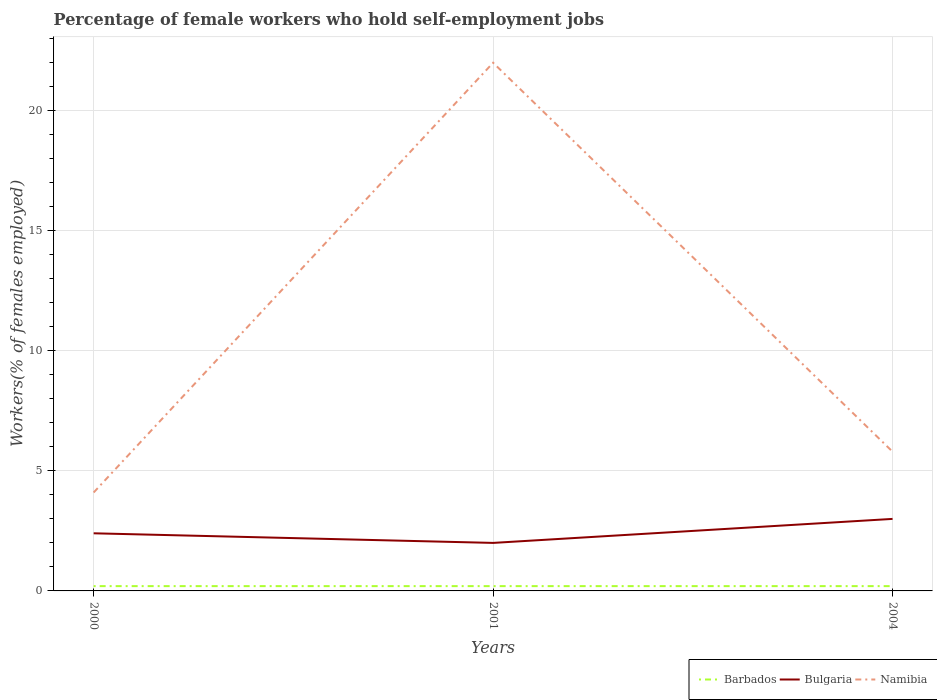How many different coloured lines are there?
Your answer should be very brief. 3. Does the line corresponding to Barbados intersect with the line corresponding to Namibia?
Keep it short and to the point. No. Across all years, what is the maximum percentage of self-employed female workers in Bulgaria?
Your answer should be compact. 2. What is the total percentage of self-employed female workers in Namibia in the graph?
Your answer should be very brief. -17.9. What is the difference between the highest and the lowest percentage of self-employed female workers in Bulgaria?
Offer a very short reply. 1. Is the percentage of self-employed female workers in Barbados strictly greater than the percentage of self-employed female workers in Bulgaria over the years?
Your response must be concise. Yes. How many lines are there?
Provide a short and direct response. 3. Does the graph contain grids?
Keep it short and to the point. Yes. Where does the legend appear in the graph?
Give a very brief answer. Bottom right. How many legend labels are there?
Offer a terse response. 3. What is the title of the graph?
Give a very brief answer. Percentage of female workers who hold self-employment jobs. What is the label or title of the X-axis?
Keep it short and to the point. Years. What is the label or title of the Y-axis?
Keep it short and to the point. Workers(% of females employed). What is the Workers(% of females employed) of Barbados in 2000?
Your response must be concise. 0.2. What is the Workers(% of females employed) of Bulgaria in 2000?
Ensure brevity in your answer.  2.4. What is the Workers(% of females employed) in Namibia in 2000?
Your response must be concise. 4.1. What is the Workers(% of females employed) in Barbados in 2001?
Give a very brief answer. 0.2. What is the Workers(% of females employed) in Bulgaria in 2001?
Your answer should be compact. 2. What is the Workers(% of females employed) in Barbados in 2004?
Your answer should be compact. 0.2. What is the Workers(% of females employed) in Bulgaria in 2004?
Ensure brevity in your answer.  3. What is the Workers(% of females employed) of Namibia in 2004?
Provide a succinct answer. 5.8. Across all years, what is the maximum Workers(% of females employed) in Barbados?
Ensure brevity in your answer.  0.2. Across all years, what is the maximum Workers(% of females employed) in Bulgaria?
Your answer should be compact. 3. Across all years, what is the maximum Workers(% of females employed) of Namibia?
Provide a succinct answer. 22. Across all years, what is the minimum Workers(% of females employed) in Barbados?
Provide a short and direct response. 0.2. Across all years, what is the minimum Workers(% of females employed) in Bulgaria?
Make the answer very short. 2. Across all years, what is the minimum Workers(% of females employed) in Namibia?
Give a very brief answer. 4.1. What is the total Workers(% of females employed) of Namibia in the graph?
Give a very brief answer. 31.9. What is the difference between the Workers(% of females employed) in Namibia in 2000 and that in 2001?
Offer a terse response. -17.9. What is the difference between the Workers(% of females employed) in Barbados in 2000 and that in 2004?
Ensure brevity in your answer.  0. What is the difference between the Workers(% of females employed) in Bulgaria in 2000 and that in 2004?
Provide a short and direct response. -0.6. What is the difference between the Workers(% of females employed) in Barbados in 2000 and the Workers(% of females employed) in Bulgaria in 2001?
Give a very brief answer. -1.8. What is the difference between the Workers(% of females employed) of Barbados in 2000 and the Workers(% of females employed) of Namibia in 2001?
Provide a succinct answer. -21.8. What is the difference between the Workers(% of females employed) in Bulgaria in 2000 and the Workers(% of females employed) in Namibia in 2001?
Provide a short and direct response. -19.6. What is the difference between the Workers(% of females employed) in Bulgaria in 2000 and the Workers(% of females employed) in Namibia in 2004?
Offer a very short reply. -3.4. What is the difference between the Workers(% of females employed) of Bulgaria in 2001 and the Workers(% of females employed) of Namibia in 2004?
Keep it short and to the point. -3.8. What is the average Workers(% of females employed) in Barbados per year?
Your answer should be compact. 0.2. What is the average Workers(% of females employed) in Bulgaria per year?
Provide a succinct answer. 2.47. What is the average Workers(% of females employed) of Namibia per year?
Keep it short and to the point. 10.63. In the year 2001, what is the difference between the Workers(% of females employed) in Barbados and Workers(% of females employed) in Bulgaria?
Your response must be concise. -1.8. In the year 2001, what is the difference between the Workers(% of females employed) of Barbados and Workers(% of females employed) of Namibia?
Make the answer very short. -21.8. In the year 2001, what is the difference between the Workers(% of females employed) of Bulgaria and Workers(% of females employed) of Namibia?
Your answer should be compact. -20. In the year 2004, what is the difference between the Workers(% of females employed) in Barbados and Workers(% of females employed) in Namibia?
Make the answer very short. -5.6. In the year 2004, what is the difference between the Workers(% of females employed) in Bulgaria and Workers(% of females employed) in Namibia?
Provide a short and direct response. -2.8. What is the ratio of the Workers(% of females employed) of Barbados in 2000 to that in 2001?
Ensure brevity in your answer.  1. What is the ratio of the Workers(% of females employed) of Namibia in 2000 to that in 2001?
Offer a terse response. 0.19. What is the ratio of the Workers(% of females employed) in Bulgaria in 2000 to that in 2004?
Offer a terse response. 0.8. What is the ratio of the Workers(% of females employed) of Namibia in 2000 to that in 2004?
Keep it short and to the point. 0.71. What is the ratio of the Workers(% of females employed) in Namibia in 2001 to that in 2004?
Ensure brevity in your answer.  3.79. What is the difference between the highest and the second highest Workers(% of females employed) in Bulgaria?
Make the answer very short. 0.6. What is the difference between the highest and the second highest Workers(% of females employed) of Namibia?
Provide a succinct answer. 16.2. What is the difference between the highest and the lowest Workers(% of females employed) in Bulgaria?
Ensure brevity in your answer.  1. 